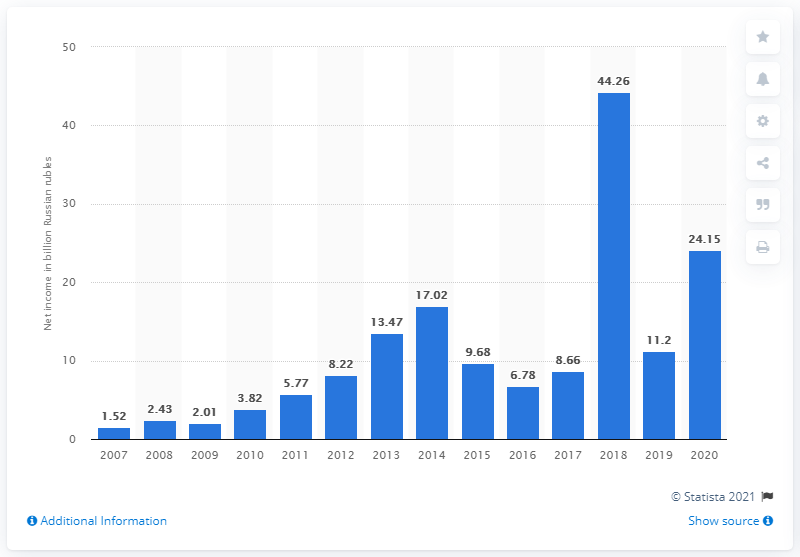List a handful of essential elements in this visual. In 2018, Yandex reported a net income of 44.26 million. In 2020, Yandex's net income was 24.15 million. 